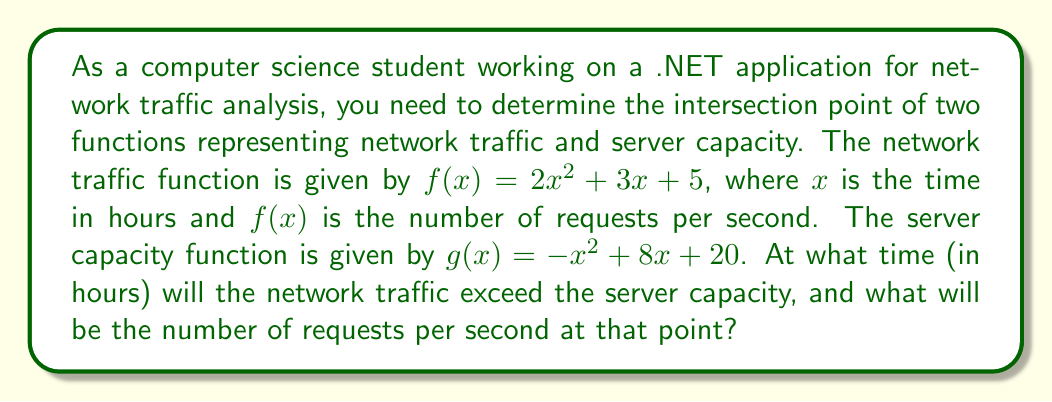Show me your answer to this math problem. To solve this problem, we need to find the intersection point of the two functions. This can be done by setting the functions equal to each other and solving for x.

1. Set the functions equal:
   $$2x^2 + 3x + 5 = -x^2 + 8x + 20$$

2. Rearrange the equation to standard form:
   $$3x^2 - 5x - 15 = 0$$

3. Use the quadratic formula to solve for x:
   $$x = \frac{-b \pm \sqrt{b^2 - 4ac}}{2a}$$
   Where $a = 3$, $b = -5$, and $c = -15$

4. Substitute the values:
   $$x = \frac{5 \pm \sqrt{(-5)^2 - 4(3)(-15)}}{2(3)}$$
   $$x = \frac{5 \pm \sqrt{25 + 180}}{6}$$
   $$x = \frac{5 \pm \sqrt{205}}{6}$$

5. Solve for x:
   $$x_1 = \frac{5 + \sqrt{205}}{6} \approx 3.39 \text{ hours}$$
   $$x_2 = \frac{5 - \sqrt{205}}{6} \approx -1.72 \text{ hours}$$

6. Since time cannot be negative, we discard the negative solution. The intersection point occurs at approximately 3.39 hours.

7. To find the number of requests per second at the intersection point, substitute x = 3.39 into either function:
   $$f(3.39) = 2(3.39)^2 + 3(3.39) + 5 \approx 39.98 \text{ requests per second}$$

Therefore, the network traffic will exceed the server capacity after approximately 3.39 hours, with both the traffic and capacity reaching about 39.98 requests per second at that point.
Answer: The network traffic will exceed the server capacity after approximately 3.39 hours, with both reaching about 39.98 requests per second at that point. 